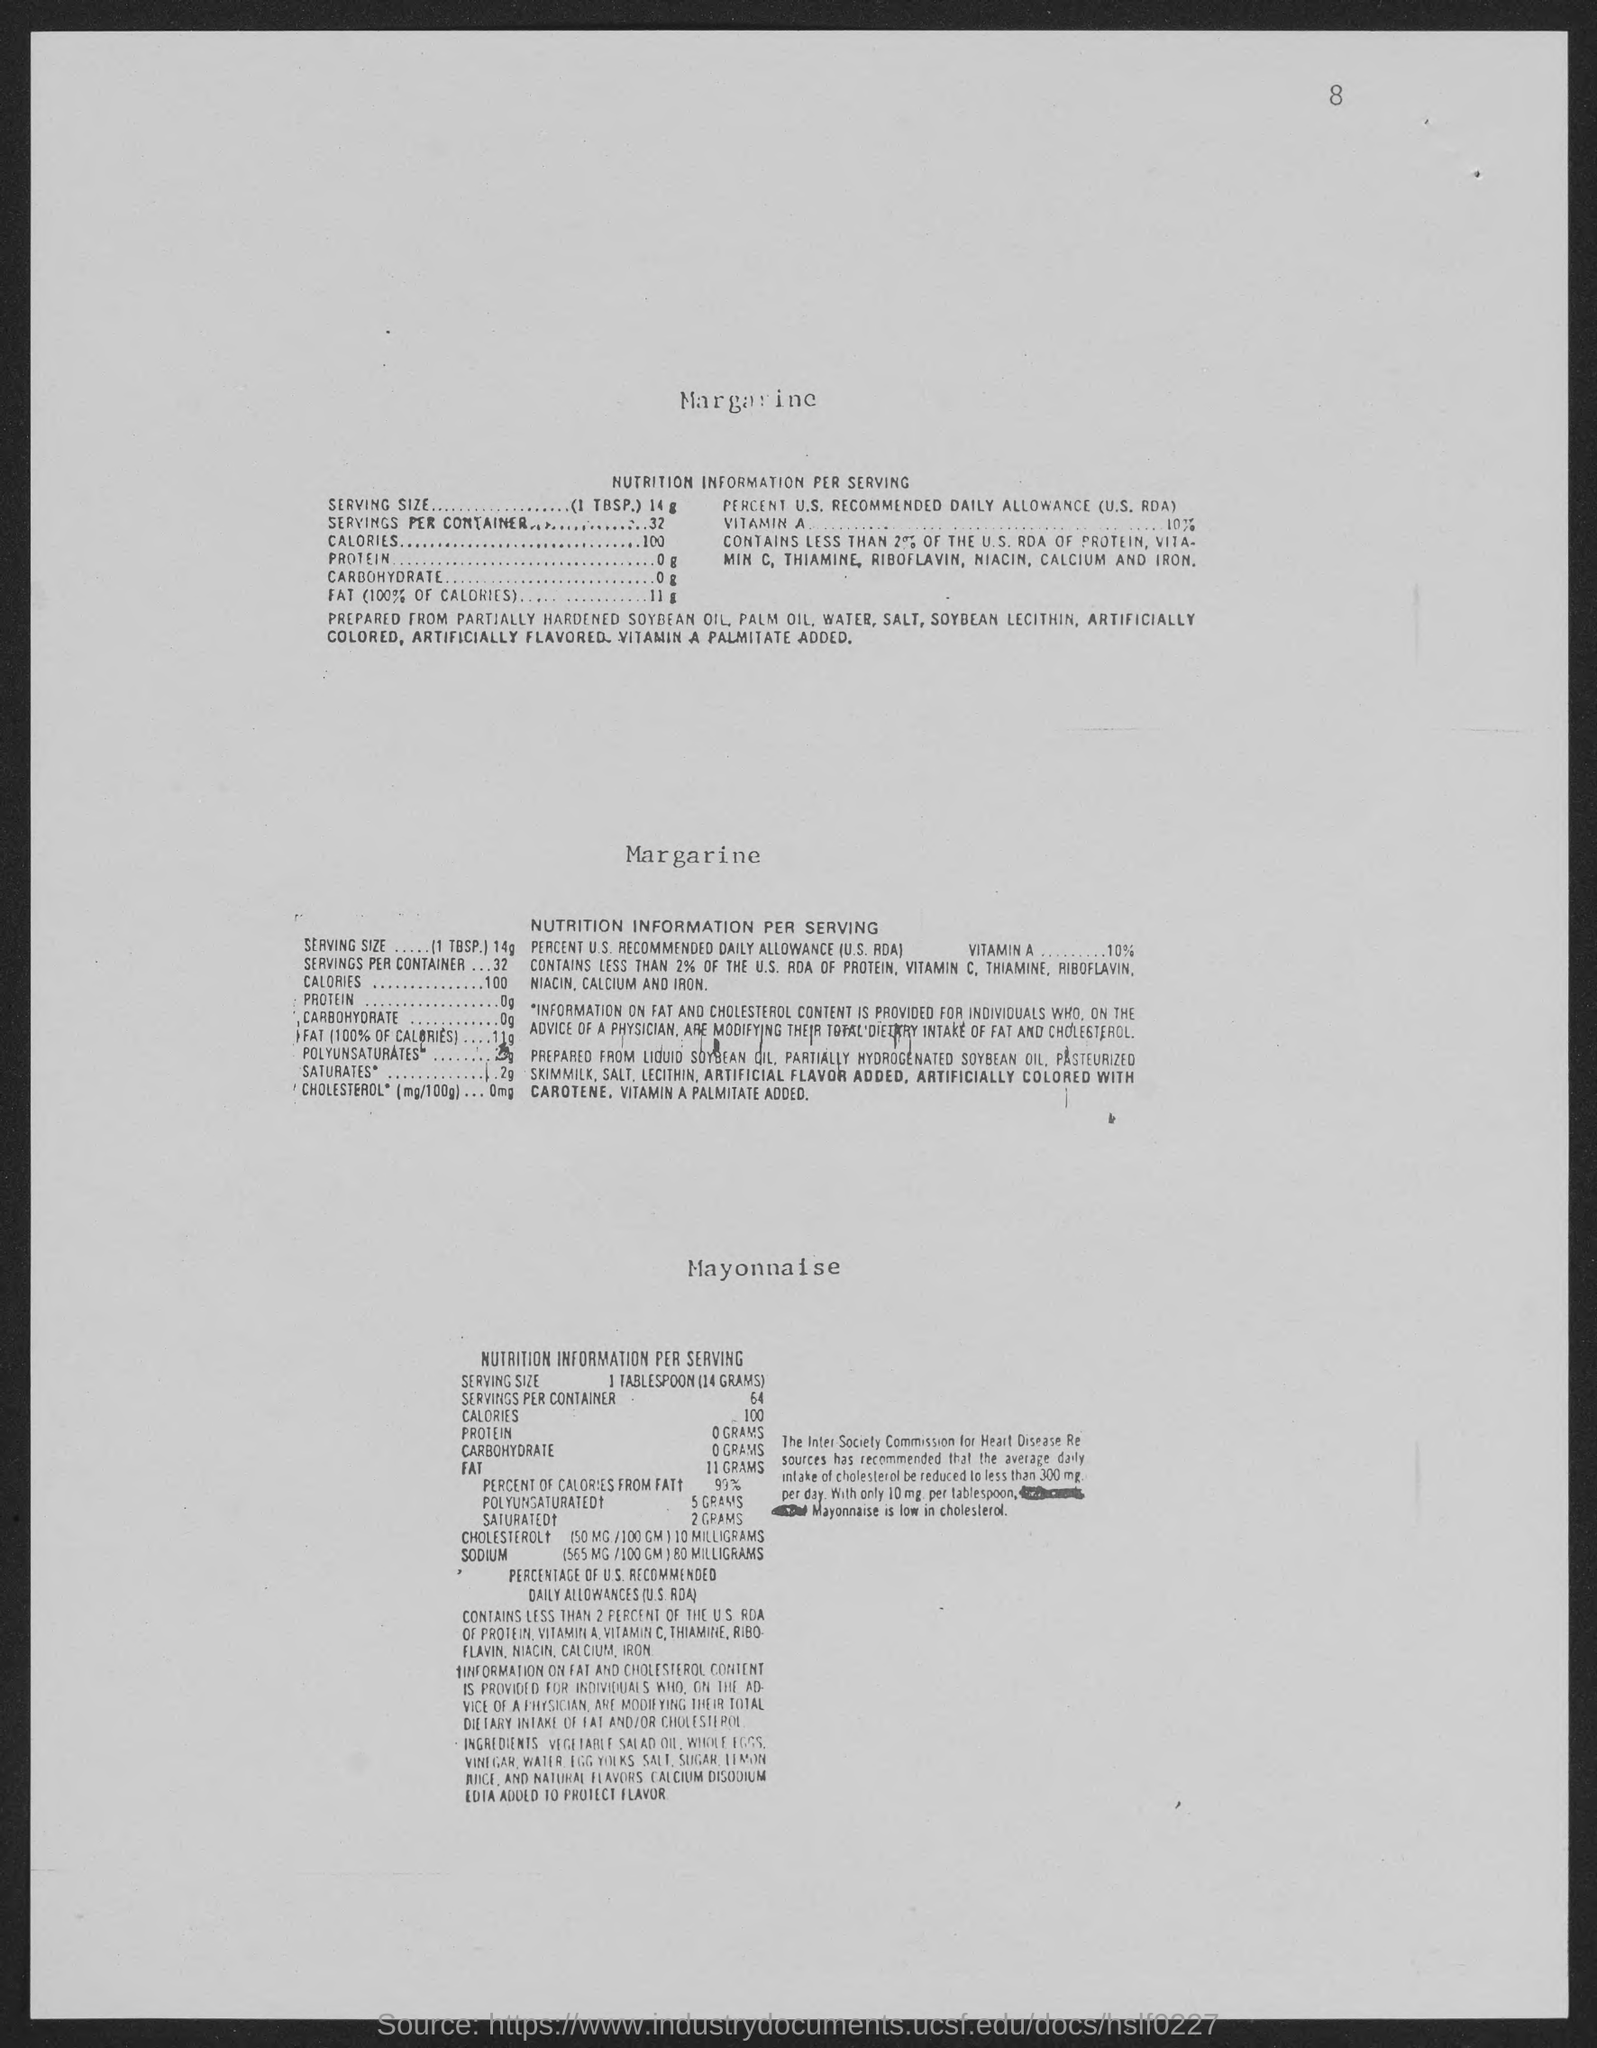Highlight a few significant elements in this photo. The number at the top-right corner of the page is 8. 